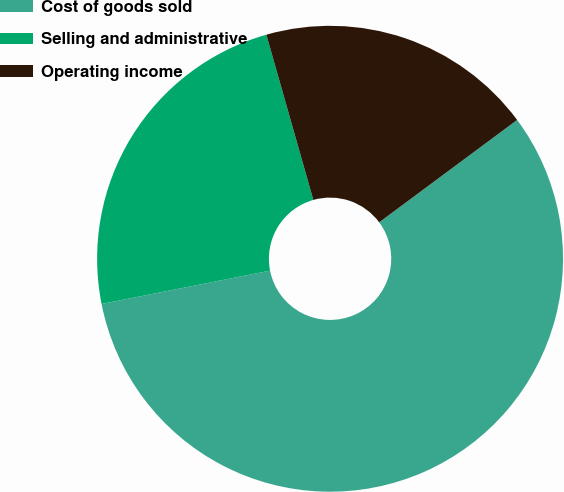Convert chart to OTSL. <chart><loc_0><loc_0><loc_500><loc_500><pie_chart><fcel>Cost of goods sold<fcel>Selling and administrative<fcel>Operating income<nl><fcel>57.05%<fcel>23.7%<fcel>19.25%<nl></chart> 